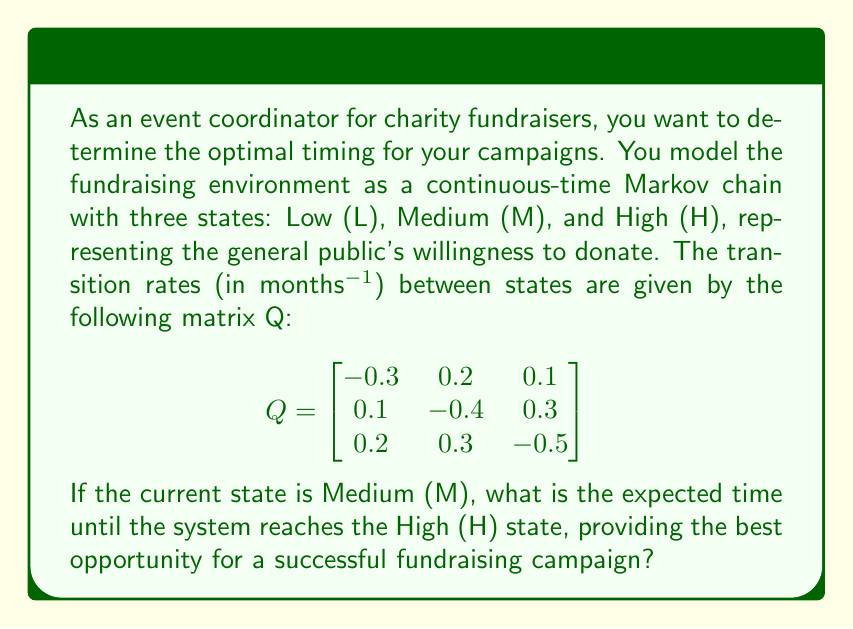Help me with this question. To solve this problem, we need to use the concept of mean first passage times in continuous-time Markov chains. Let's approach this step-by-step:

1) First, we need to set up the system of equations for mean first passage times. Let $m_{ij}$ be the mean time to go from state i to state j. We're interested in $m_{MH}$.

2) The general formula for mean first passage times is:

   $m_{ij} = -\frac{1}{q_{ii}} + \sum_{k \neq j} \frac{q_{ik}}{q_{ii}} m_{kj}$

   where $q_{ij}$ are the elements of the Q matrix.

3) In our case, we need to solve two equations:

   $m_{MH} = -\frac{1}{q_{MM}} + \frac{q_{ML}}{q_{MM}} m_{LH} + \frac{q_{MM}}{q_{MM}} \cdot 0$

   $m_{LH} = -\frac{1}{q_{LL}} + \frac{q_{LM}}{q_{LL}} m_{MH} + \frac{q_{LH}}{q_{LL}} \cdot 0$

4) Substituting the values from the Q matrix:

   $m_{MH} = \frac{1}{0.4} + \frac{0.1}{0.4} m_{LH}$

   $m_{LH} = \frac{1}{0.3} + \frac{0.2}{0.3} m_{MH}$

5) Now we have a system of two equations with two unknowns. Let's solve for $m_{MH}$:

   $m_{MH} = 2.5 + 0.25m_{LH}$
   $m_{LH} = 3.33 + 0.67m_{MH}$

6) Substitute the second equation into the first:

   $m_{MH} = 2.5 + 0.25(3.33 + 0.67m_{MH})$
   $m_{MH} = 2.5 + 0.83 + 0.17m_{MH}$
   $0.83m_{MH} = 3.33$
   $m_{MH} = 4$

Therefore, starting from the Medium state, the expected time to reach the High state is 4 months.
Answer: 4 months 